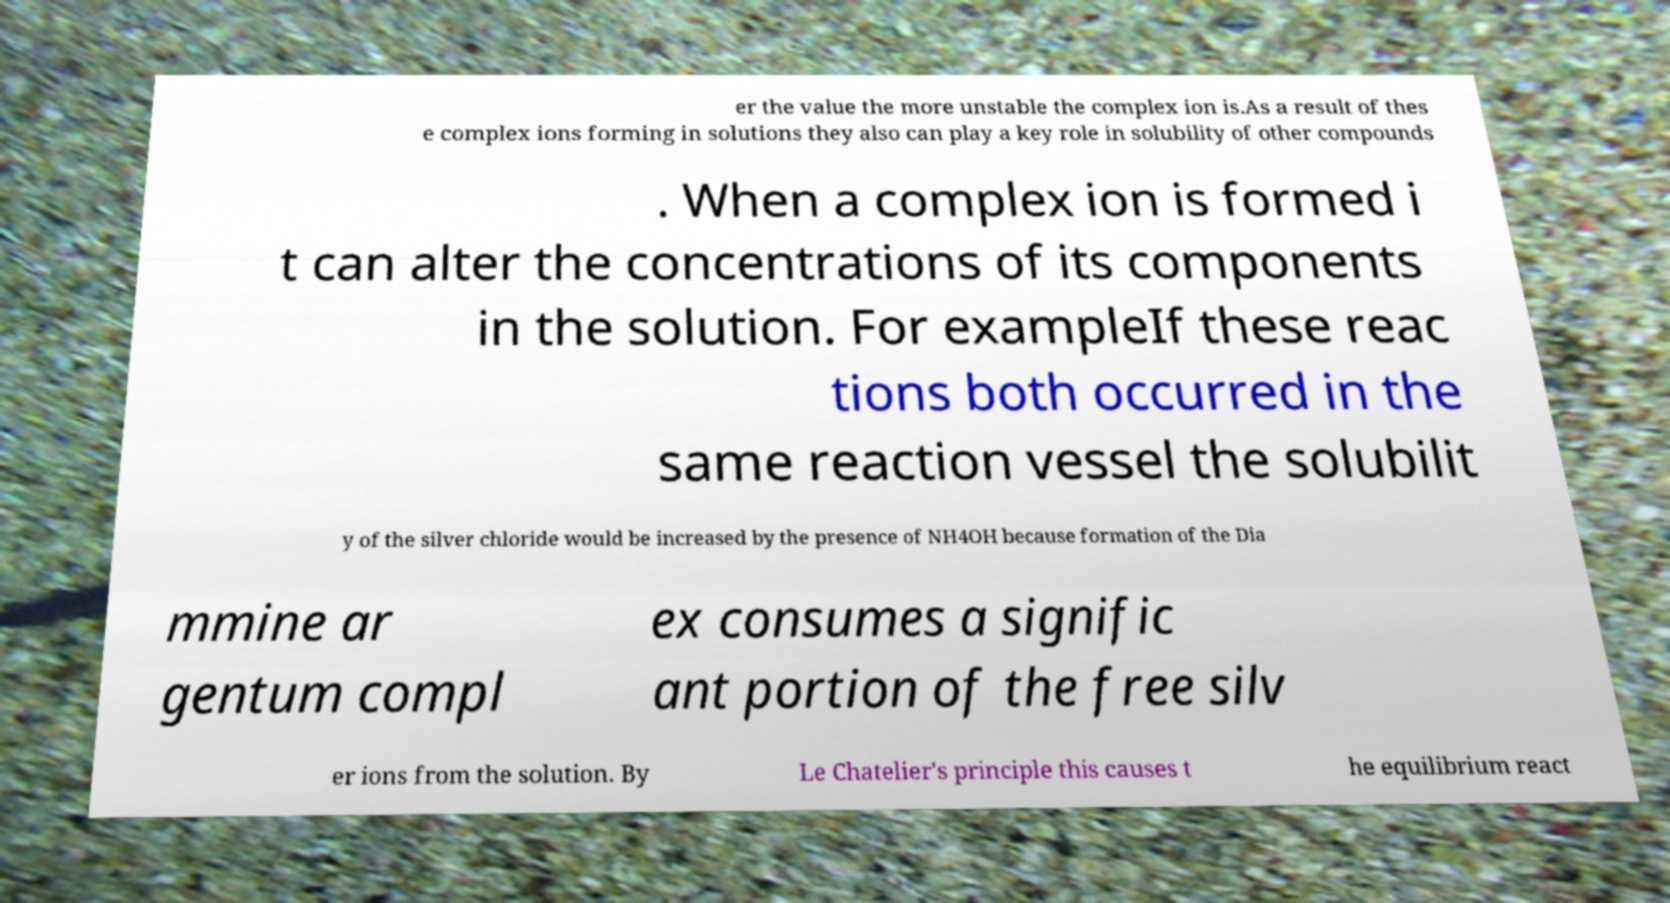Can you accurately transcribe the text from the provided image for me? er the value the more unstable the complex ion is.As a result of thes e complex ions forming in solutions they also can play a key role in solubility of other compounds . When a complex ion is formed i t can alter the concentrations of its components in the solution. For exampleIf these reac tions both occurred in the same reaction vessel the solubilit y of the silver chloride would be increased by the presence of NH4OH because formation of the Dia mmine ar gentum compl ex consumes a signific ant portion of the free silv er ions from the solution. By Le Chatelier's principle this causes t he equilibrium react 